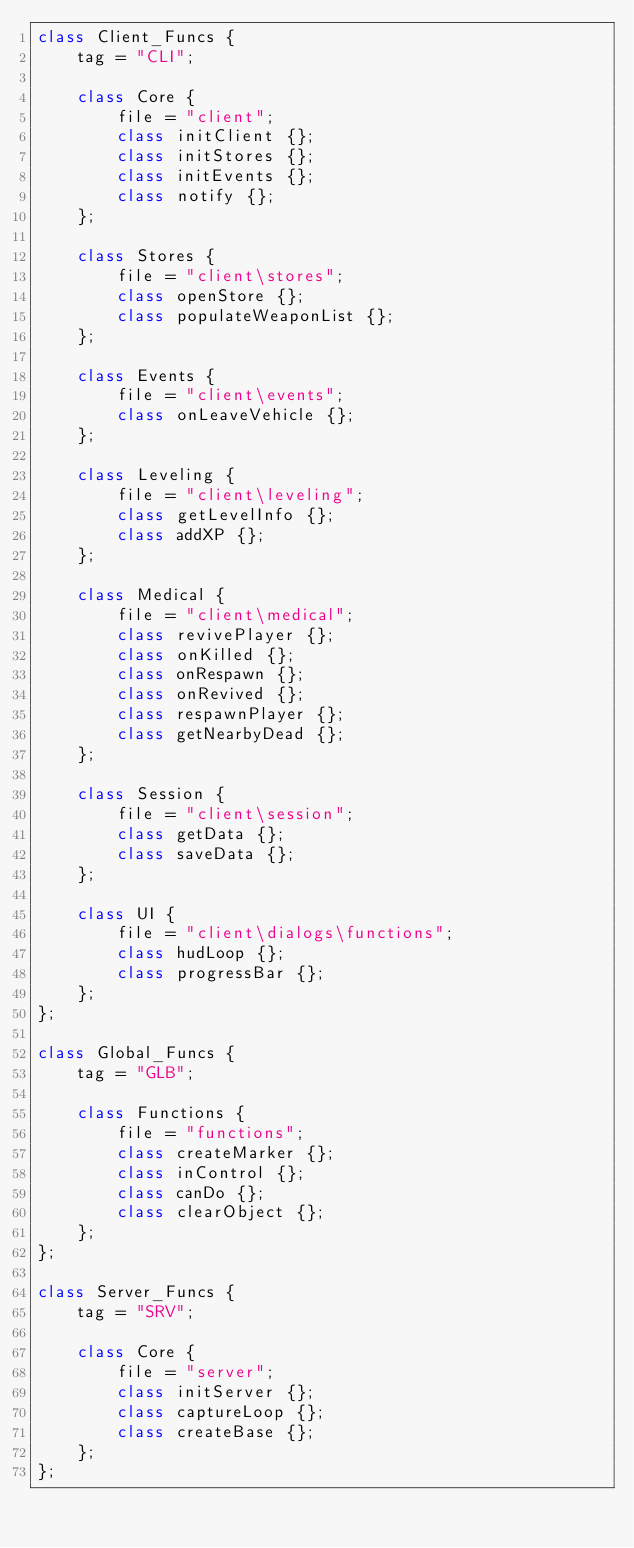<code> <loc_0><loc_0><loc_500><loc_500><_C++_>class Client_Funcs {
	tag = "CLI";

	class Core {
		file = "client";
		class initClient {};
		class initStores {};
		class initEvents {};
		class notify {};
	};
	
	class Stores {
		file = "client\stores";
		class openStore {};
		class populateWeaponList {};
	};

	class Events {
		file = "client\events";
		class onLeaveVehicle {};
	};

	class Leveling {
		file = "client\leveling";
		class getLevelInfo {};
		class addXP {};
	};

	class Medical {
		file = "client\medical";
		class revivePlayer {};
		class onKilled {};
		class onRespawn {};
		class onRevived {};
		class respawnPlayer {};
		class getNearbyDead {};
	};

	class Session {
		file = "client\session";
		class getData {};
		class saveData {};
	};

	class UI {
		file = "client\dialogs\functions";
		class hudLoop {};
		class progressBar {};
	};
};

class Global_Funcs {
	tag = "GLB";

	class Functions {
		file = "functions";
		class createMarker {};
		class inControl {};
		class canDo {};
		class clearObject {};
	};
};

class Server_Funcs {
	tag = "SRV";

	class Core {
		file = "server";
		class initServer {};
		class captureLoop {};
		class createBase {};
	};
};</code> 